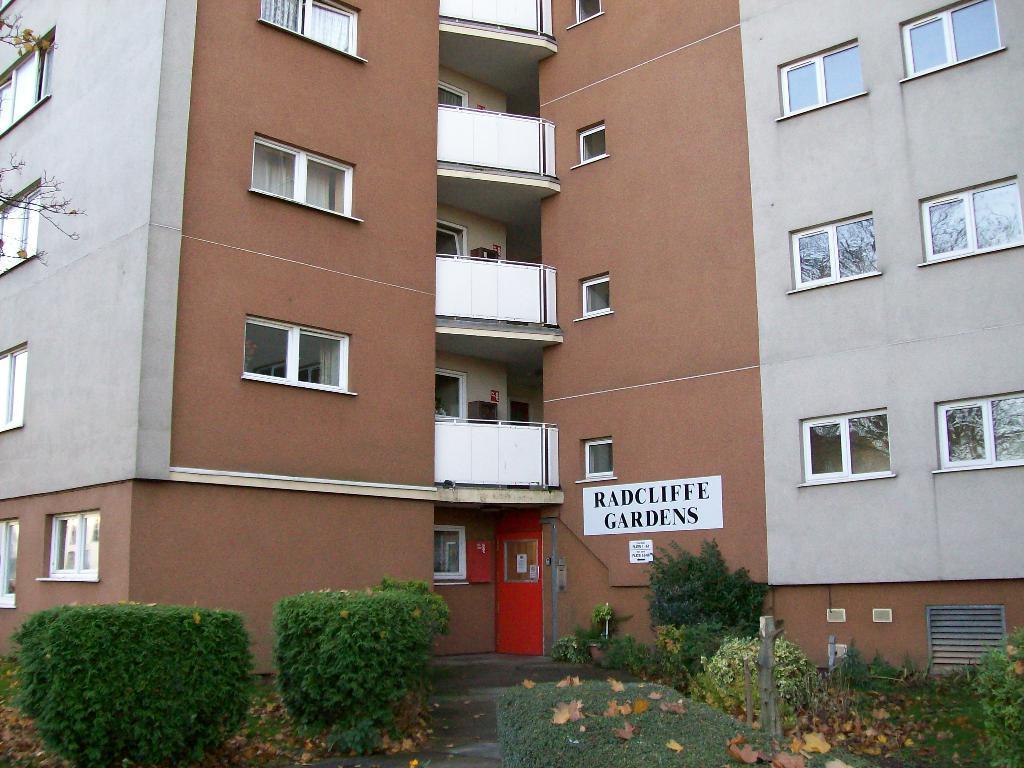In one or two sentences, can you explain what this image depicts? In this image I can see the plants. In the background, I can see the building with the windows. I can also see some text written on wall. 